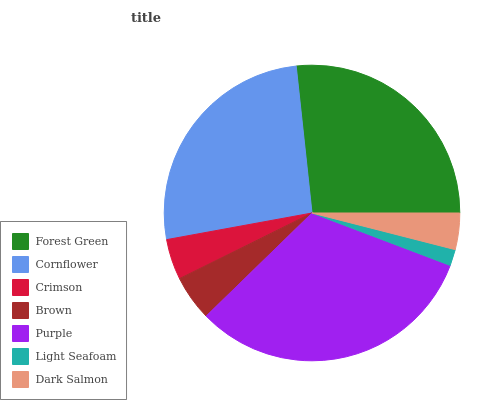Is Light Seafoam the minimum?
Answer yes or no. Yes. Is Purple the maximum?
Answer yes or no. Yes. Is Cornflower the minimum?
Answer yes or no. No. Is Cornflower the maximum?
Answer yes or no. No. Is Forest Green greater than Cornflower?
Answer yes or no. Yes. Is Cornflower less than Forest Green?
Answer yes or no. Yes. Is Cornflower greater than Forest Green?
Answer yes or no. No. Is Forest Green less than Cornflower?
Answer yes or no. No. Is Brown the high median?
Answer yes or no. Yes. Is Brown the low median?
Answer yes or no. Yes. Is Purple the high median?
Answer yes or no. No. Is Purple the low median?
Answer yes or no. No. 